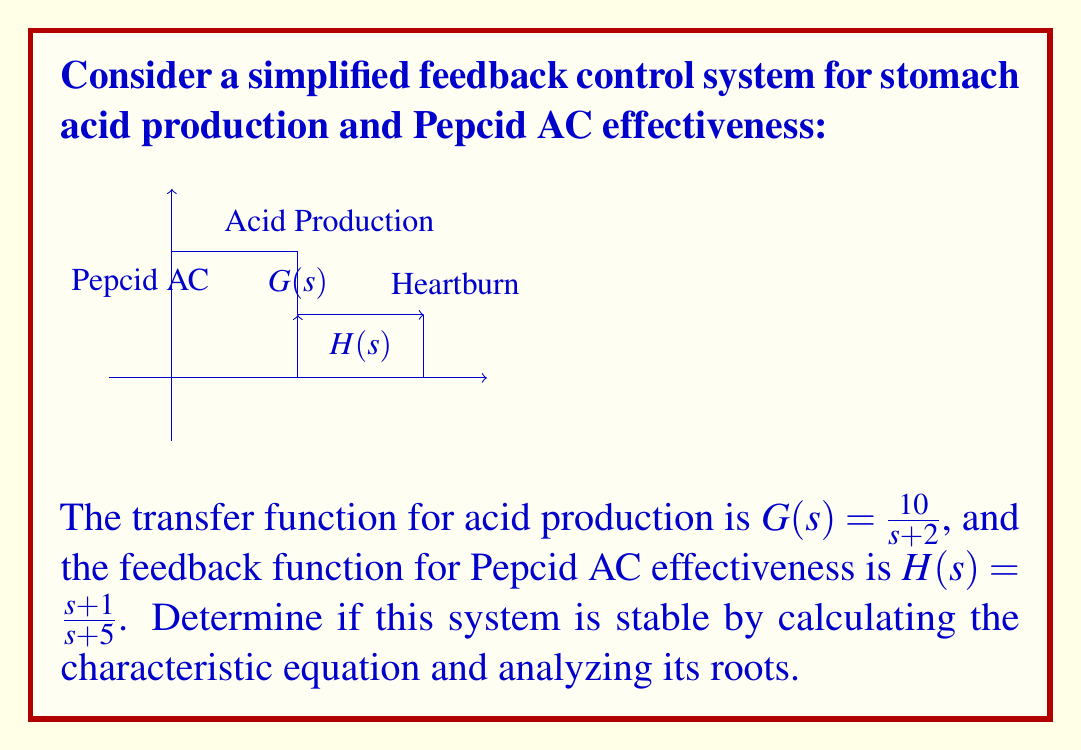What is the answer to this math problem? To analyze the stability of this feedback system, we need to follow these steps:

1. Determine the closed-loop transfer function:
   The general form of a closed-loop transfer function is:
   $$T(s) = \frac{G(s)}{1 + G(s)H(s)}$$

2. Substitute the given transfer functions:
   $$T(s) = \frac{\frac{10}{s+2}}{1 + \frac{10}{s+2} \cdot \frac{s+1}{s+5}}$$

3. Find the characteristic equation by setting the denominator to zero:
   $$1 + \frac{10}{s+2} \cdot \frac{s+1}{s+5} = 0$$

4. Multiply all terms by $(s+2)(s+5)$:
   $$(s+2)(s+5) + 10(s+1) = 0$$

5. Expand the equation:
   $$s^2 + 7s + 10 + 10s + 10 = 0$$
   $$s^2 + 17s + 20 = 0$$

6. This is our characteristic equation. For stability, all roots must have negative real parts.

7. Solve the quadratic equation:
   $$s = \frac{-17 \pm \sqrt{17^2 - 4(1)(20)}}{2(1)}$$
   $$s = \frac{-17 \pm \sqrt{289 - 80}}{2}$$
   $$s = \frac{-17 \pm \sqrt{209}}{2}$$

8. Calculate the roots:
   $$s_1 \approx -15.23$$
   $$s_2 \approx -1.77$$

Both roots have negative real parts, which means the system is stable.
Answer: The system is stable. 